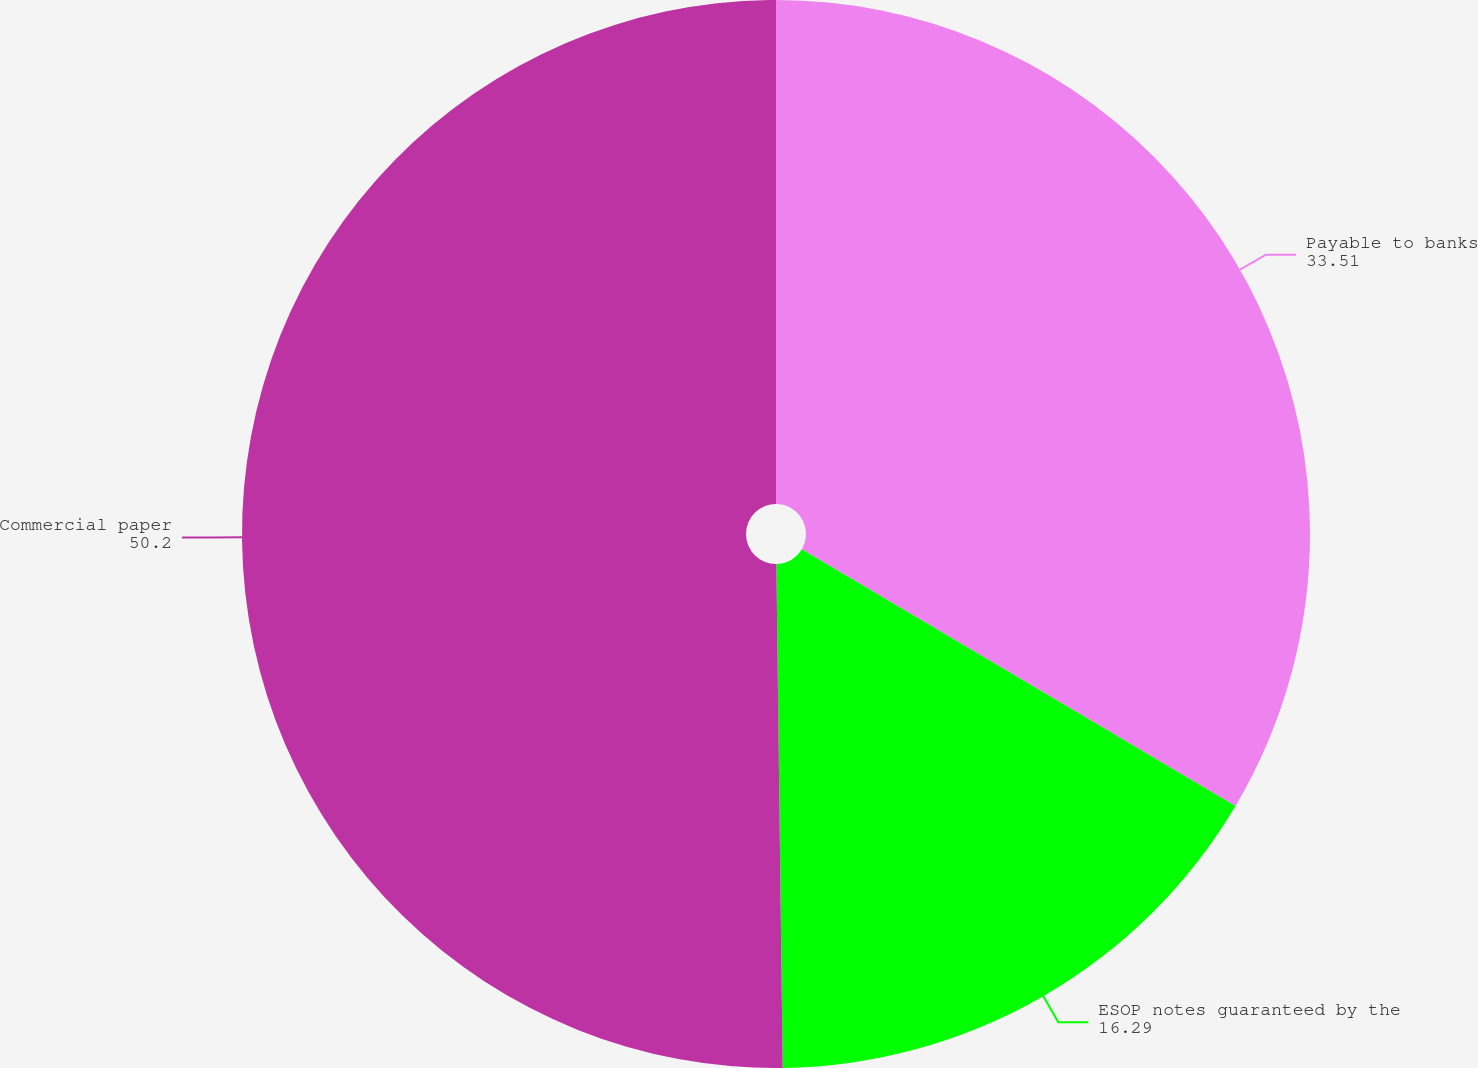Convert chart to OTSL. <chart><loc_0><loc_0><loc_500><loc_500><pie_chart><fcel>Payable to banks<fcel>ESOP notes guaranteed by the<fcel>Commercial paper<nl><fcel>33.51%<fcel>16.29%<fcel>50.2%<nl></chart> 